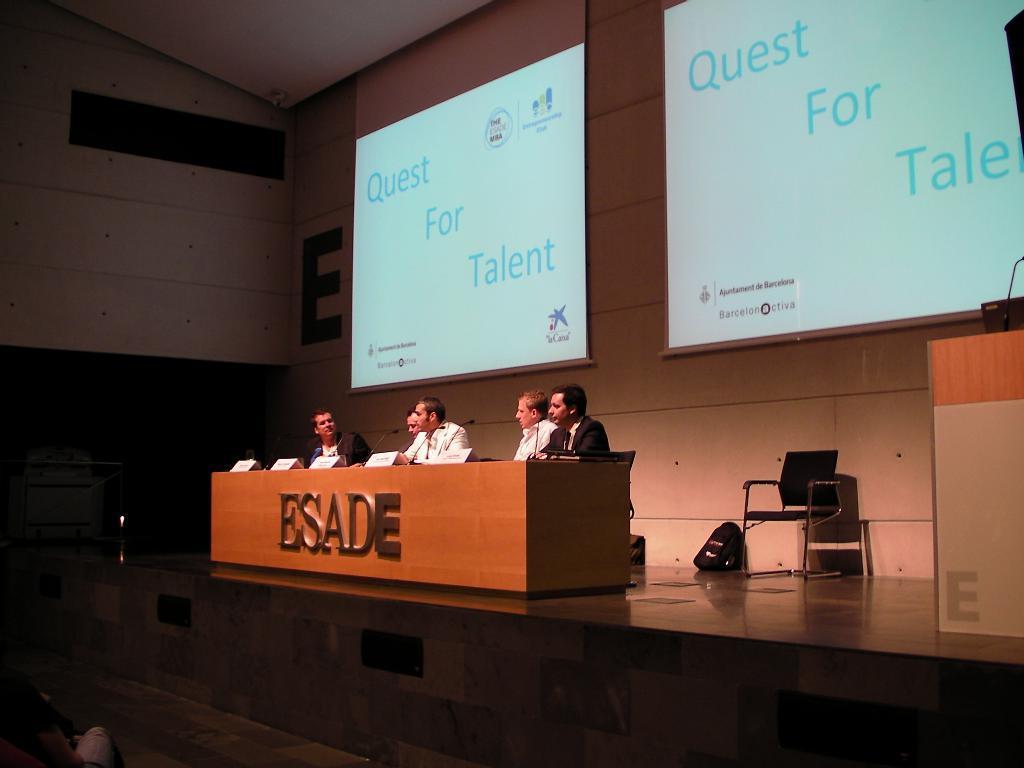Describe this image in one or two sentences. This picture might be taken inside a conference hall. In this image, on the right side, there is a podium. On that podium there is a laptop and a microphone. In the middle, we can see group of people sitting on the chair in front of a table. On the left corner, we can see a person sitting on the chair. In the background there are some screens. On top there is a roof. 